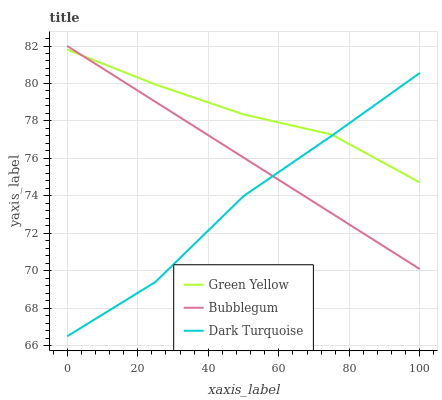Does Dark Turquoise have the minimum area under the curve?
Answer yes or no. Yes. Does Green Yellow have the maximum area under the curve?
Answer yes or no. Yes. Does Bubblegum have the minimum area under the curve?
Answer yes or no. No. Does Bubblegum have the maximum area under the curve?
Answer yes or no. No. Is Bubblegum the smoothest?
Answer yes or no. Yes. Is Dark Turquoise the roughest?
Answer yes or no. Yes. Is Green Yellow the smoothest?
Answer yes or no. No. Is Green Yellow the roughest?
Answer yes or no. No. Does Dark Turquoise have the lowest value?
Answer yes or no. Yes. Does Bubblegum have the lowest value?
Answer yes or no. No. Does Bubblegum have the highest value?
Answer yes or no. Yes. Does Green Yellow have the highest value?
Answer yes or no. No. Does Dark Turquoise intersect Green Yellow?
Answer yes or no. Yes. Is Dark Turquoise less than Green Yellow?
Answer yes or no. No. Is Dark Turquoise greater than Green Yellow?
Answer yes or no. No. 